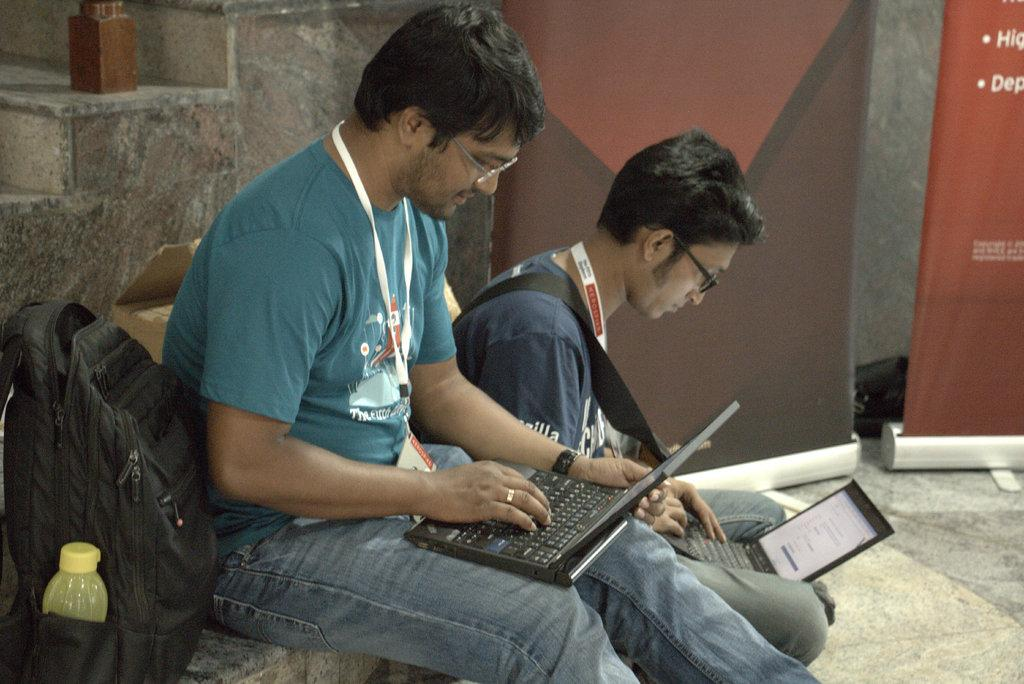How many people are present in the image? There are two people in the image. What are the people holding in the image? The people are holding laptops. What object can be seen on the bench in the image? There is a bag on the bench. What can be seen in the background of the image? There are banners and stairs visible in the background. What type of eggnog is being served at the cemetery in the image? There is no eggnog or cemetery present in the image; it features two people holding laptops, a bag on the bench, and banners and stairs in the background. 